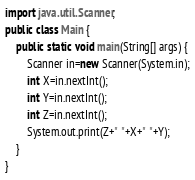<code> <loc_0><loc_0><loc_500><loc_500><_Java_>
import java.util.Scanner;
public class Main {
	public static void main(String[] args) {
		Scanner in=new Scanner(System.in);
		int X=in.nextInt();
		int Y=in.nextInt();
		int Z=in.nextInt();
		System.out.print(Z+" "+X+" "+Y);
	}
}
</code> 